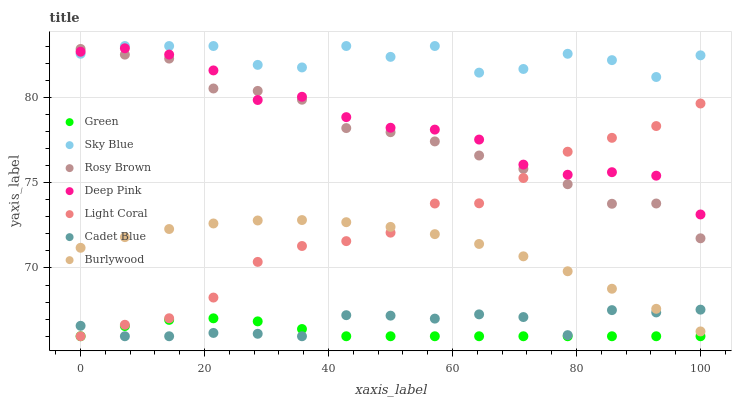Does Green have the minimum area under the curve?
Answer yes or no. Yes. Does Sky Blue have the maximum area under the curve?
Answer yes or no. Yes. Does Burlywood have the minimum area under the curve?
Answer yes or no. No. Does Burlywood have the maximum area under the curve?
Answer yes or no. No. Is Green the smoothest?
Answer yes or no. Yes. Is Sky Blue the roughest?
Answer yes or no. Yes. Is Burlywood the smoothest?
Answer yes or no. No. Is Burlywood the roughest?
Answer yes or no. No. Does Cadet Blue have the lowest value?
Answer yes or no. Yes. Does Burlywood have the lowest value?
Answer yes or no. No. Does Sky Blue have the highest value?
Answer yes or no. Yes. Does Burlywood have the highest value?
Answer yes or no. No. Is Green less than Rosy Brown?
Answer yes or no. Yes. Is Rosy Brown greater than Cadet Blue?
Answer yes or no. Yes. Does Green intersect Light Coral?
Answer yes or no. Yes. Is Green less than Light Coral?
Answer yes or no. No. Is Green greater than Light Coral?
Answer yes or no. No. Does Green intersect Rosy Brown?
Answer yes or no. No. 